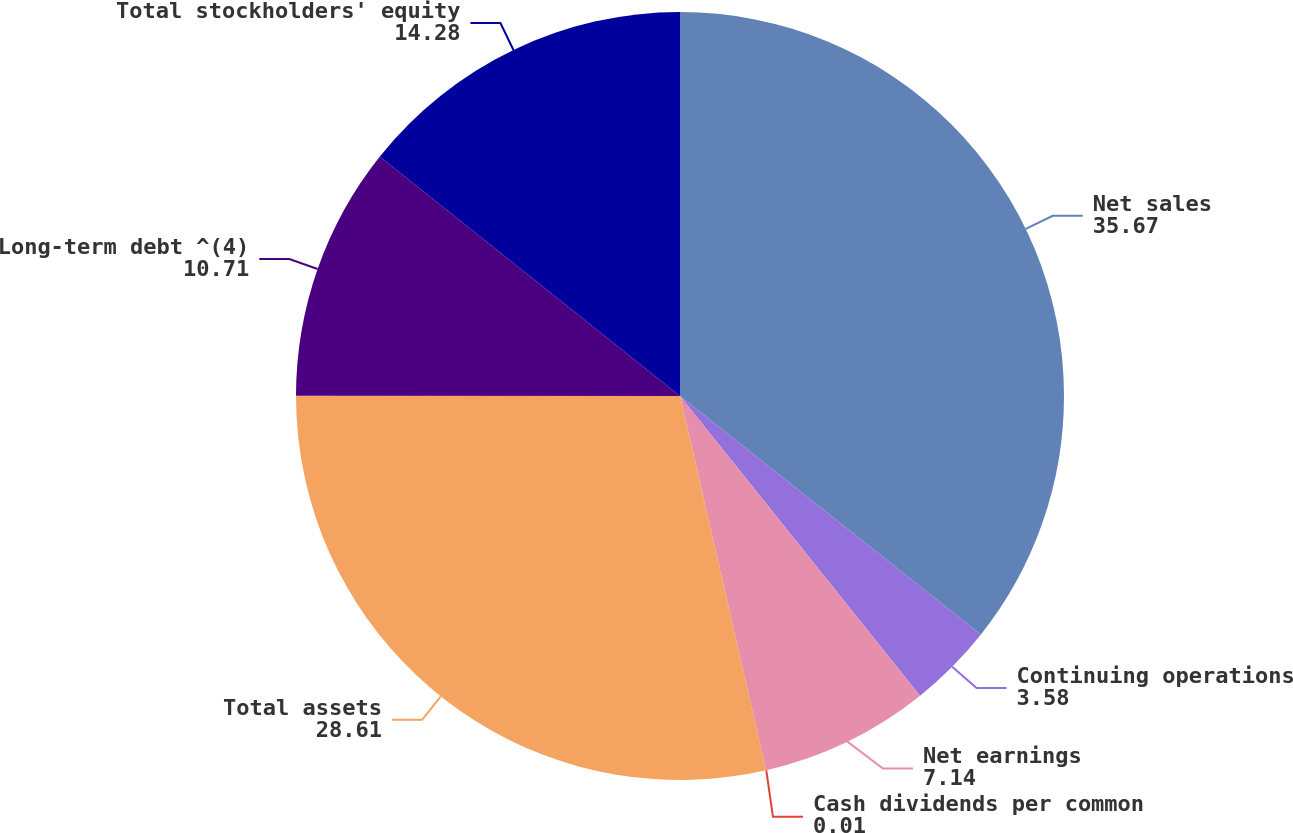Convert chart. <chart><loc_0><loc_0><loc_500><loc_500><pie_chart><fcel>Net sales<fcel>Continuing operations<fcel>Net earnings<fcel>Cash dividends per common<fcel>Total assets<fcel>Long-term debt ^(4)<fcel>Total stockholders' equity<nl><fcel>35.67%<fcel>3.58%<fcel>7.14%<fcel>0.01%<fcel>28.61%<fcel>10.71%<fcel>14.28%<nl></chart> 